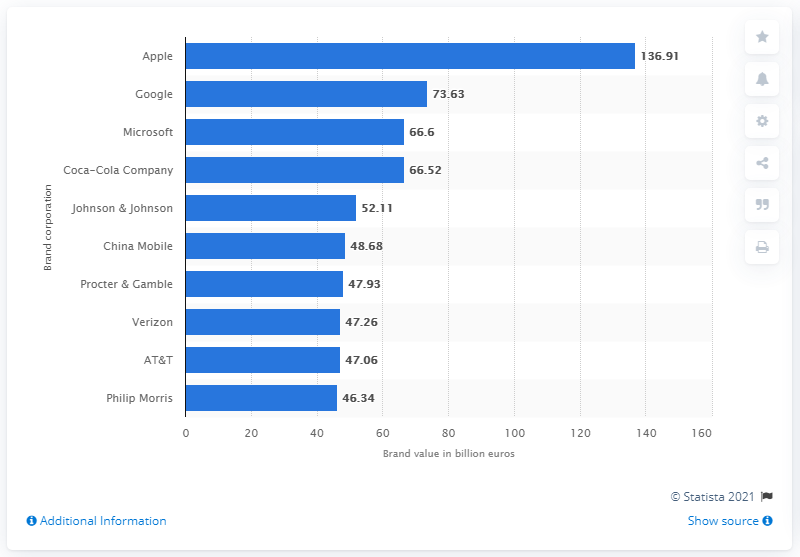Draw attention to some important aspects in this diagram. Google was ranked as the second most valuable tech brand in 2015. In 2015, Apple's estimated value was 136.91. 